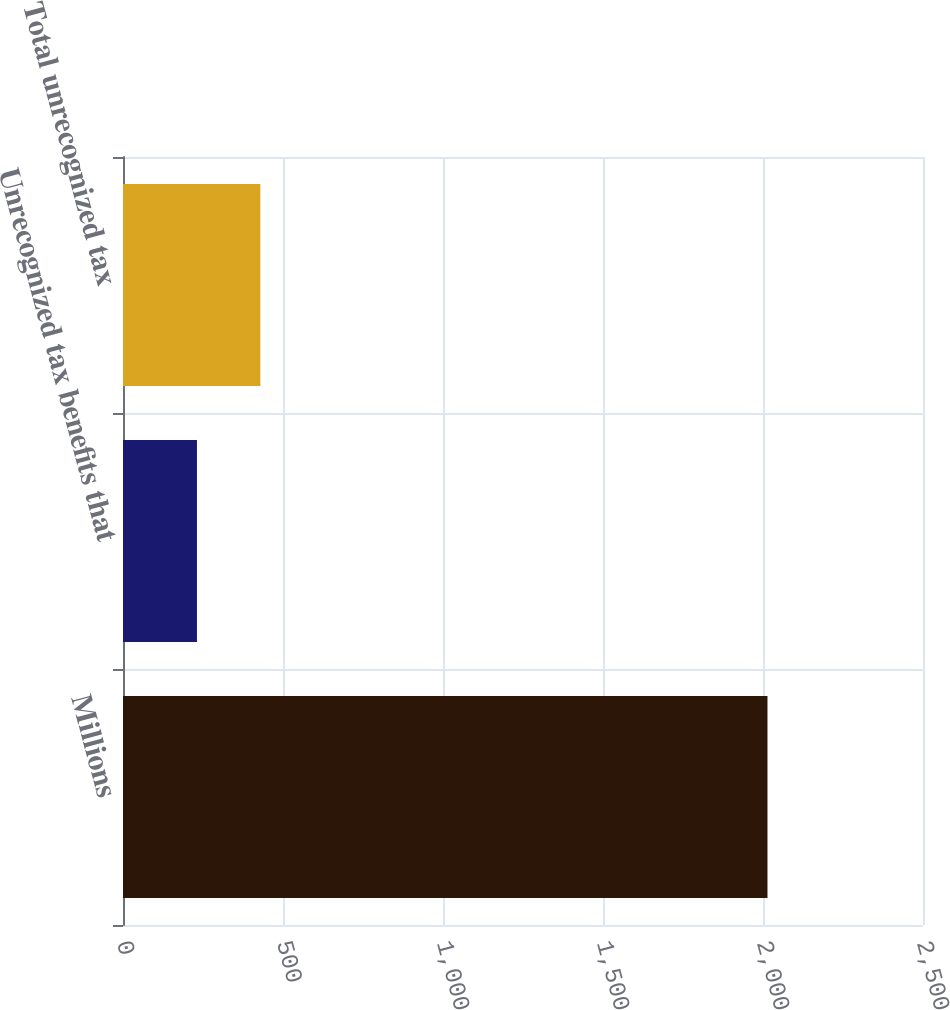Convert chart to OTSL. <chart><loc_0><loc_0><loc_500><loc_500><bar_chart><fcel>Millions<fcel>Unrecognized tax benefits that<fcel>Total unrecognized tax<nl><fcel>2014<fcel>231.1<fcel>429.2<nl></chart> 